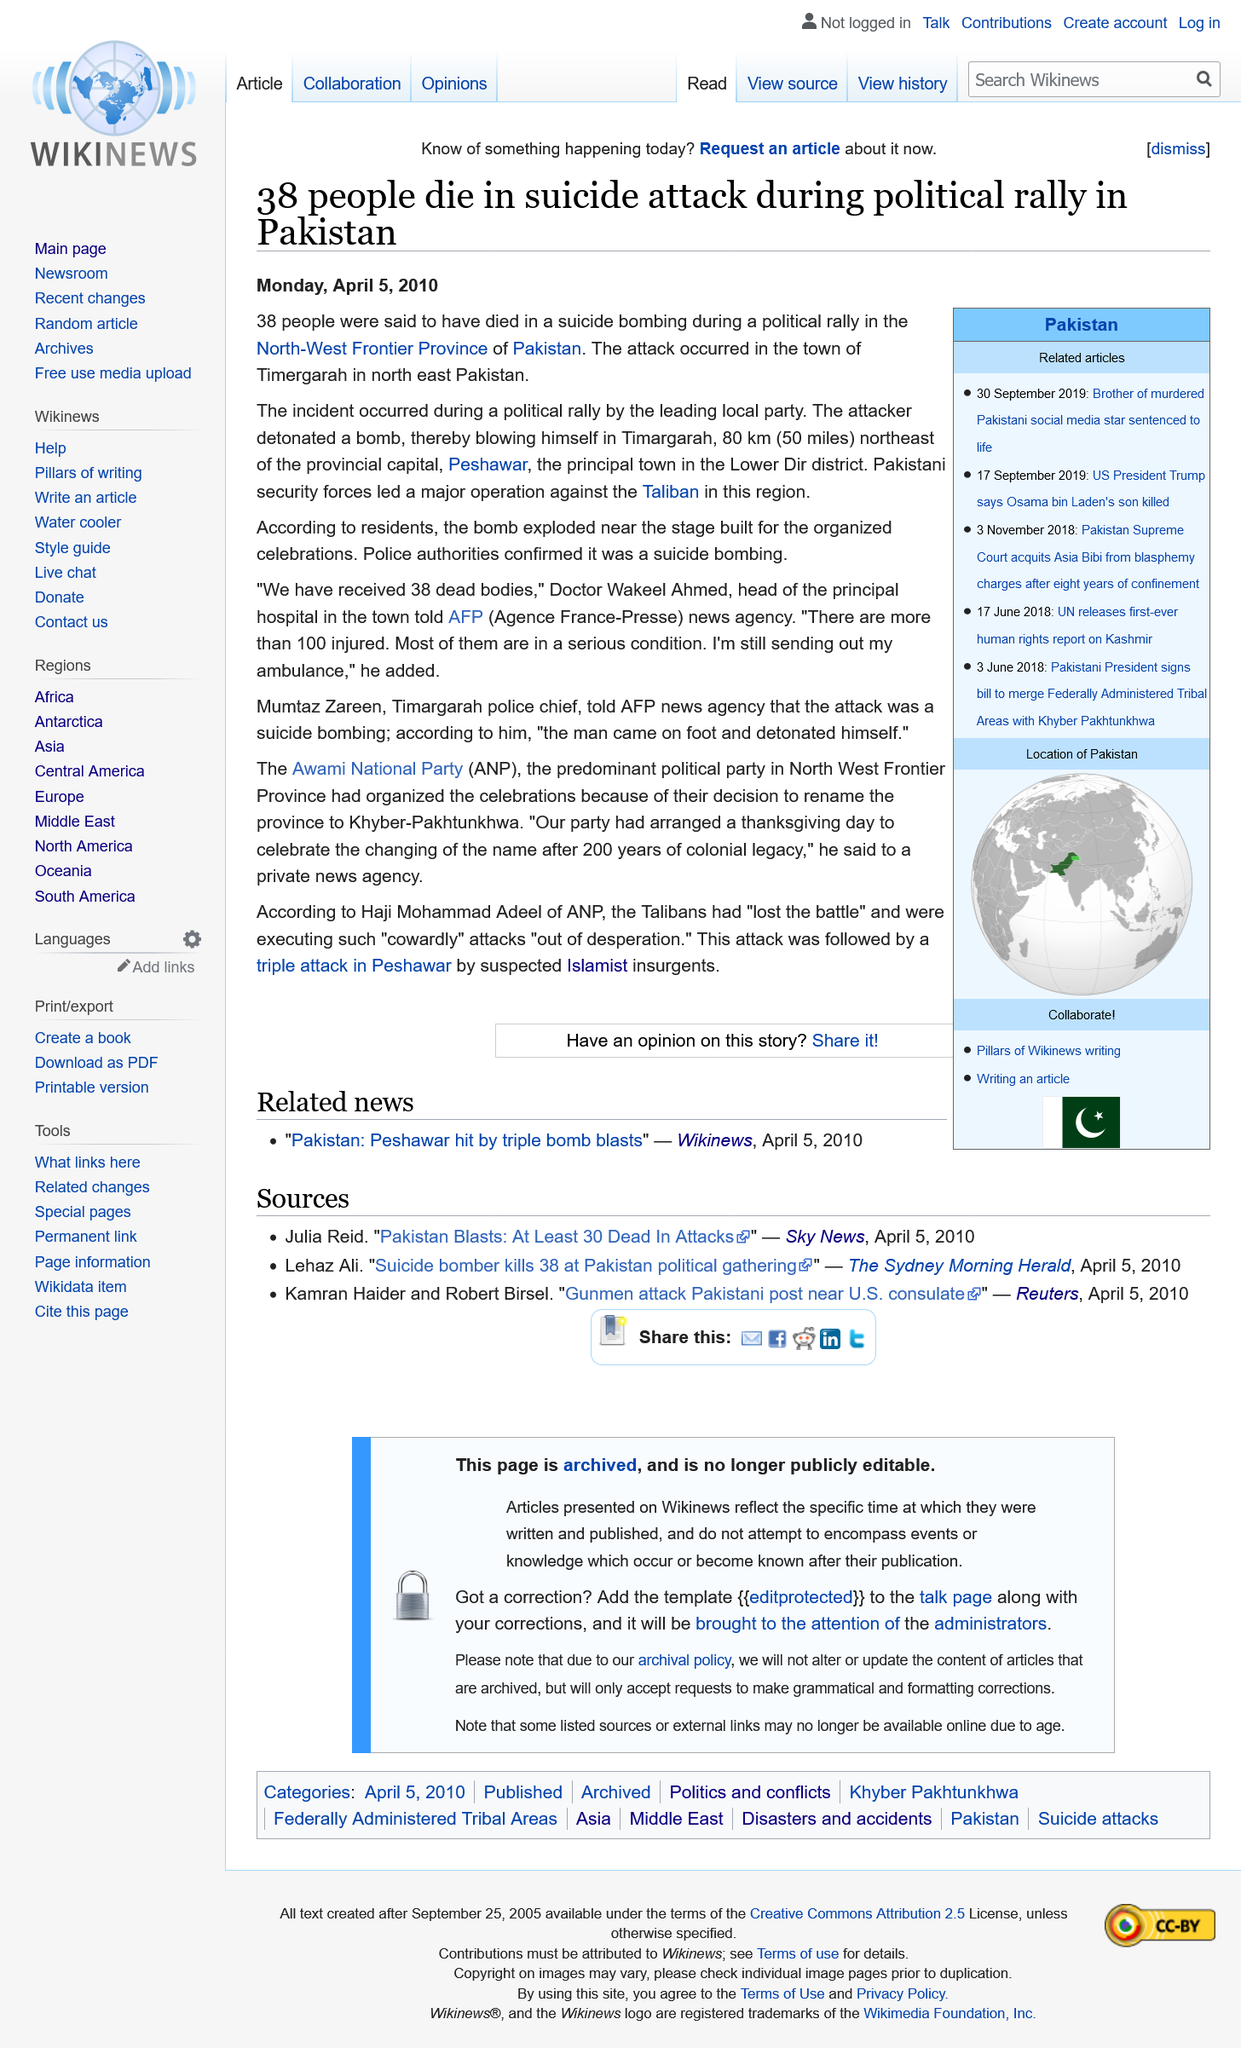Outline some significant characteristics in this image. The report regarding the suicide attack in Pakistan, which is dated Monday, April 5, 2010, provides information regarding the date of the suicide attack in Pakistan. On February 2nd, a suicide attack took place in the town of Timergarah in Pakistan, resulting in the deaths of several individuals. The attack was carried out by a group of unknown assailants, and the circumstances surrounding the attack are currently under investigation. However, what is clear is that this tragic event has left an impact on the community and the country as a whole. The people of Timergarah and the government of Pakistan are grieving the loss of life and working to come to terms with the aftermath of this devastating attack. A suicide bombing in Pakistan is believed to have resulted in the deaths of 38 people. 